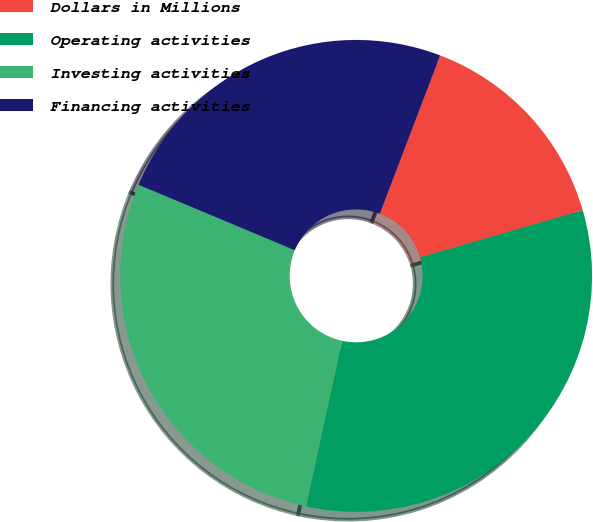Convert chart to OTSL. <chart><loc_0><loc_0><loc_500><loc_500><pie_chart><fcel>Dollars in Millions<fcel>Operating activities<fcel>Investing activities<fcel>Financing activities<nl><fcel>14.72%<fcel>32.89%<fcel>27.91%<fcel>24.48%<nl></chart> 